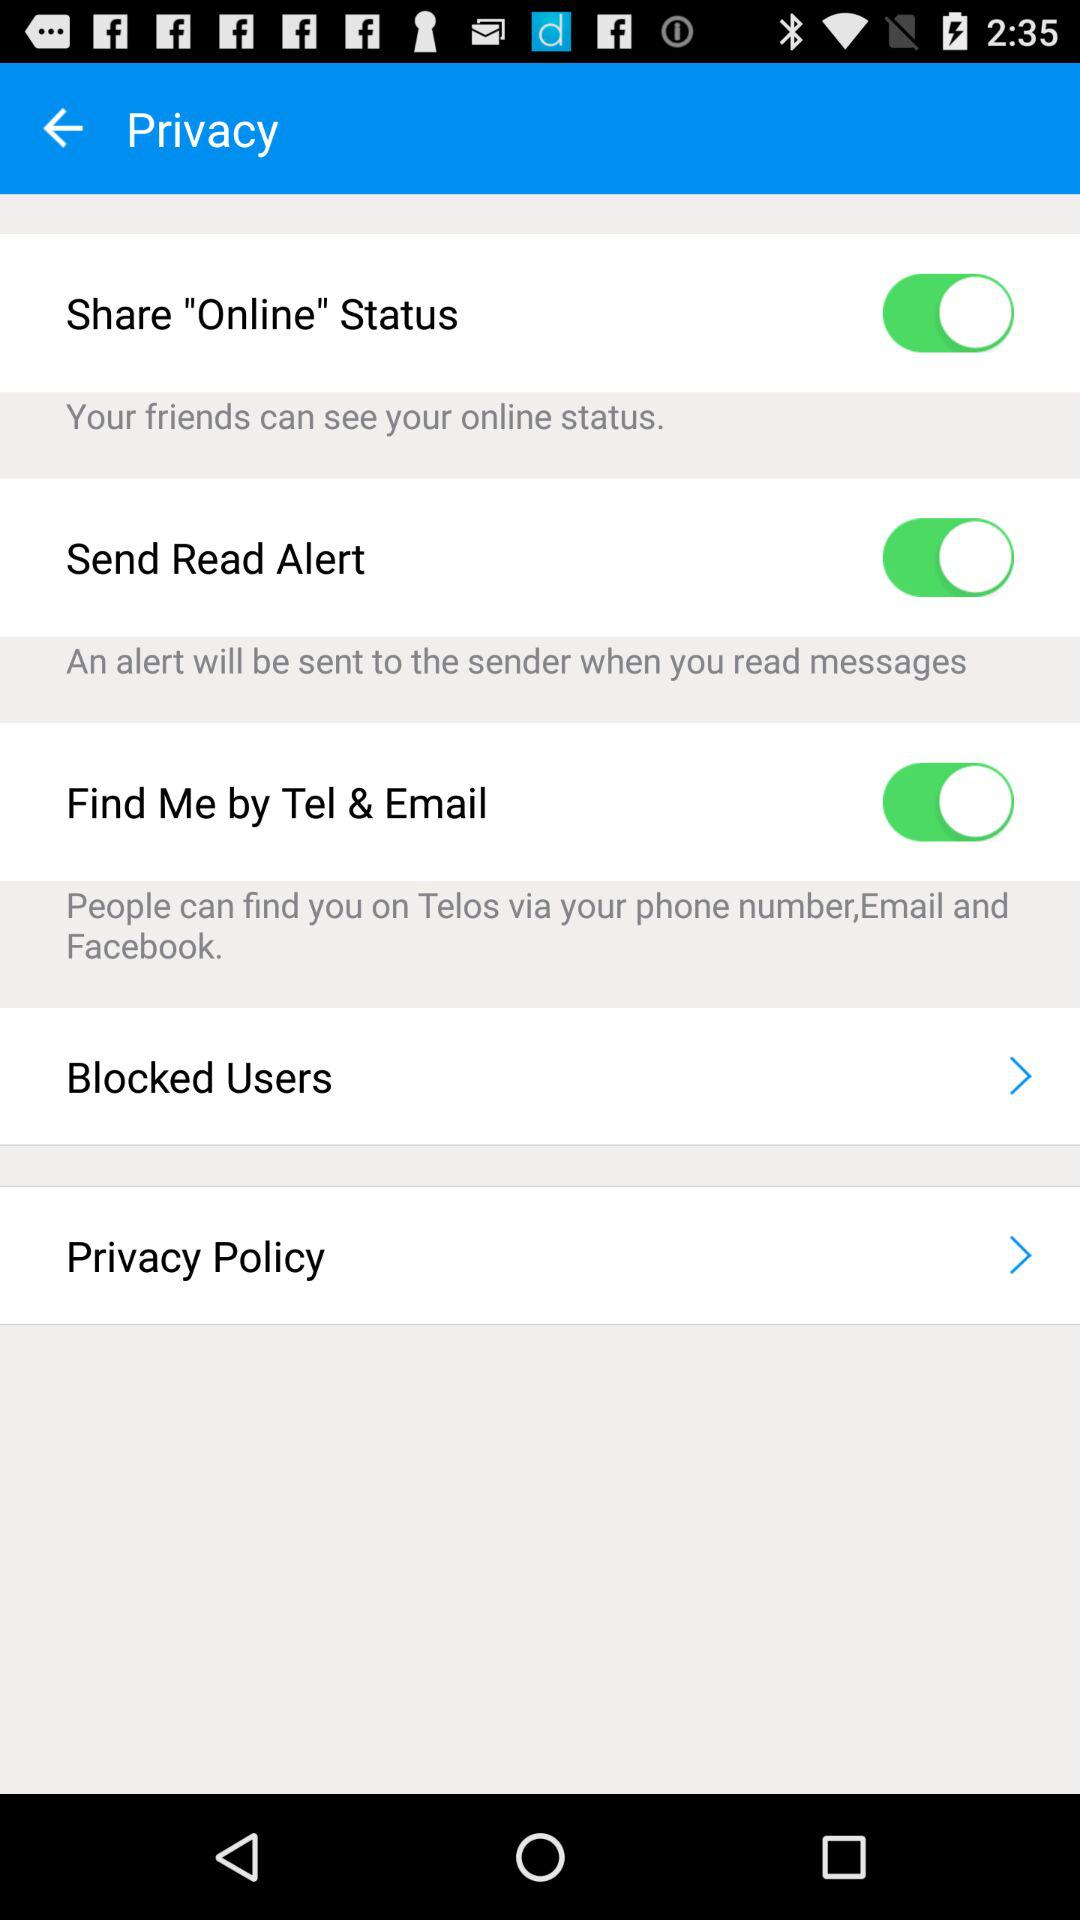How many items have a switch?
Answer the question using a single word or phrase. 3 